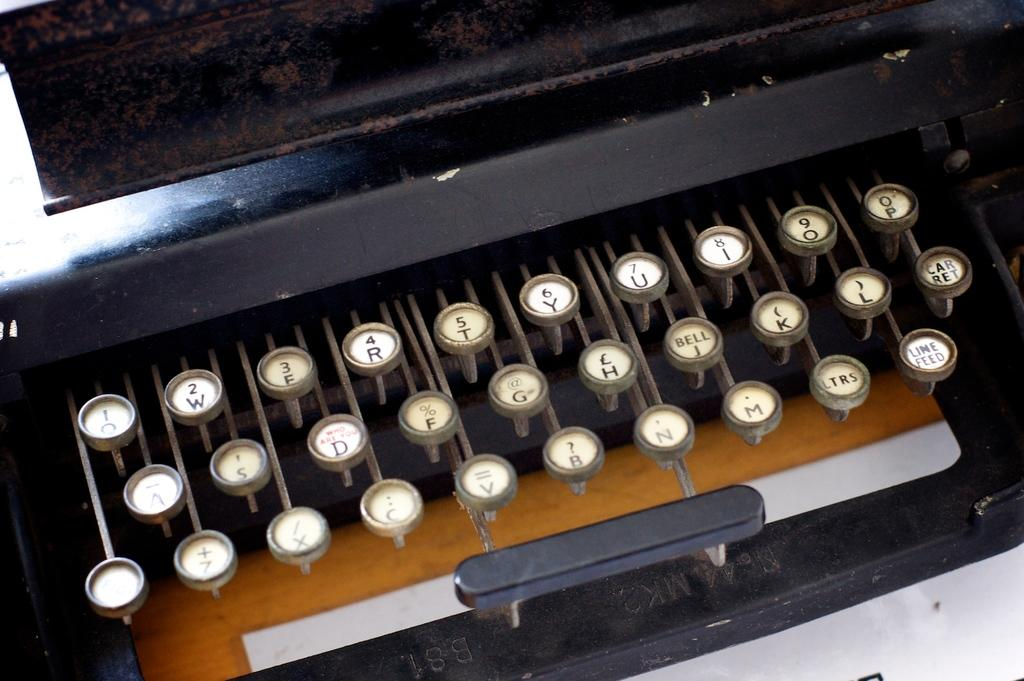<image>
Share a concise interpretation of the image provided. A keyboard has the word bell on the J key. 